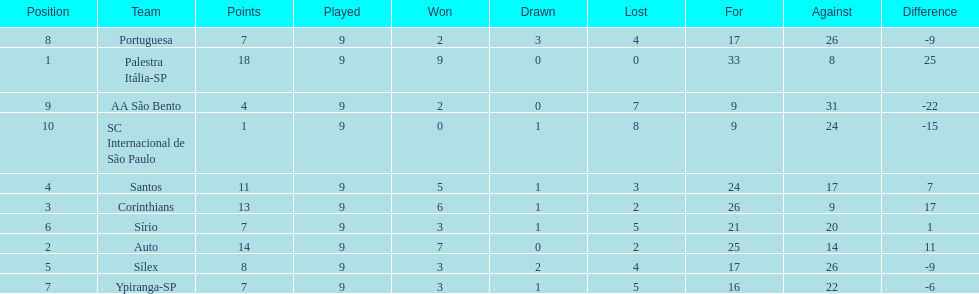What is the only squad to accumulate 13 points in 9 encounters? Corinthians. 